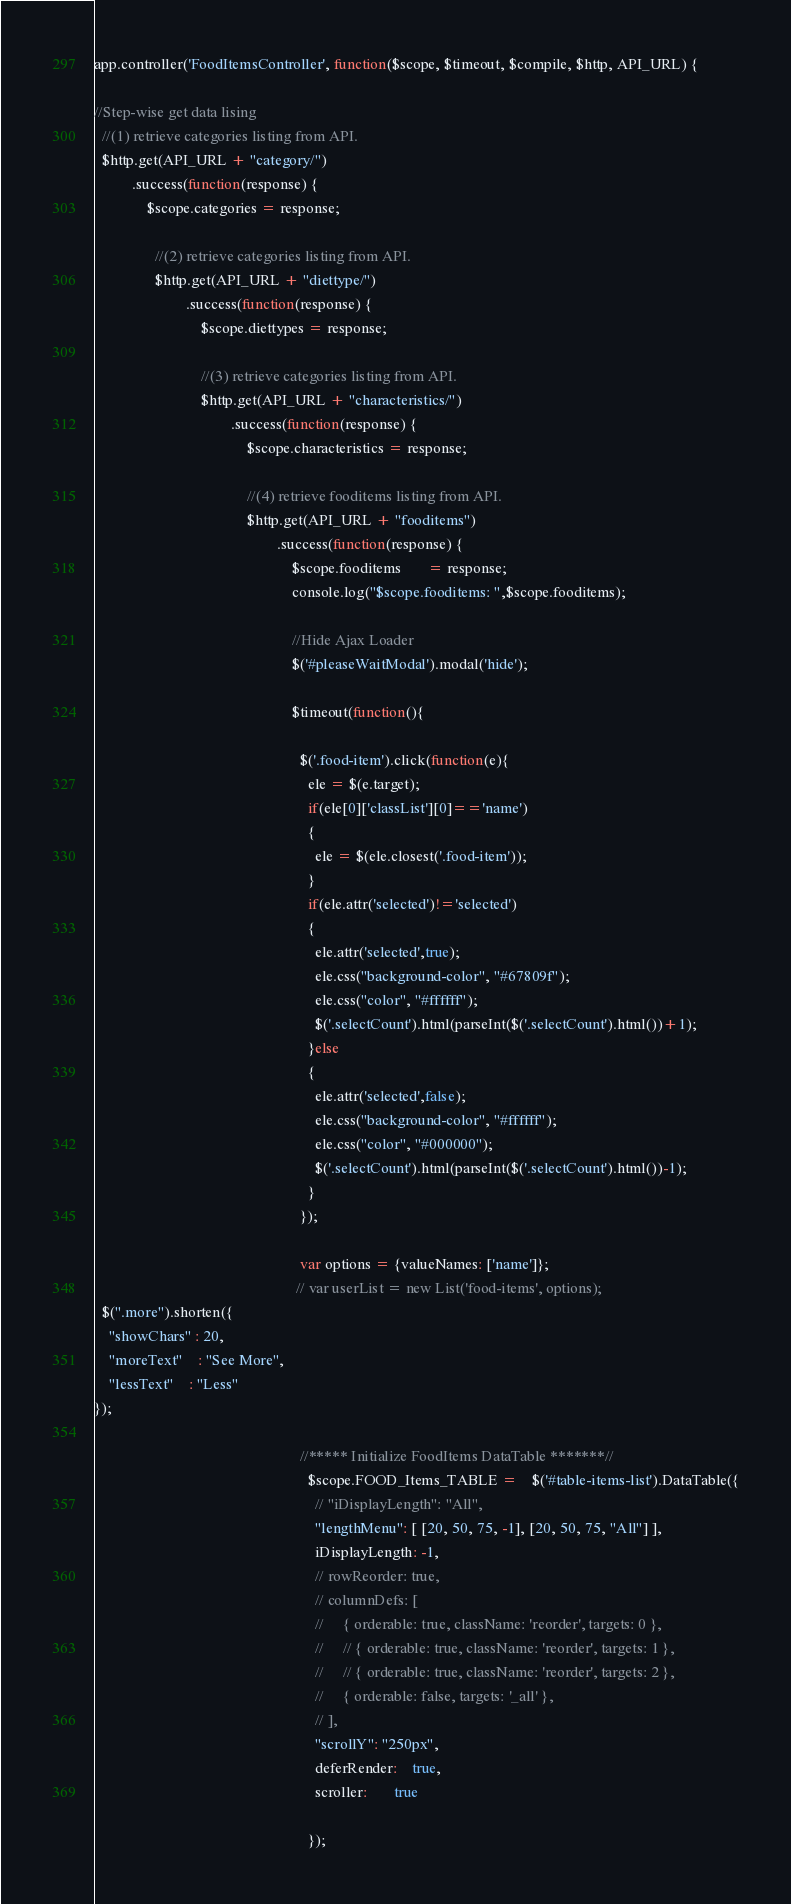<code> <loc_0><loc_0><loc_500><loc_500><_JavaScript_>app.controller('FoodItemsController', function($scope, $timeout, $compile, $http, API_URL) {

//Step-wise get data lising
  //(1) retrieve categories listing from API.
  $http.get(API_URL + "category/")
          .success(function(response) {
              $scope.categories = response;

                //(2) retrieve categories listing from API.
                $http.get(API_URL + "diettype/")
                        .success(function(response) {
                            $scope.diettypes = response;

                            //(3) retrieve categories listing from API.
                            $http.get(API_URL + "characteristics/")
                                    .success(function(response) {
                                        $scope.characteristics = response;

                                        //(4) retrieve fooditems listing from API.
                                        $http.get(API_URL + "fooditems")
                                                .success(function(response) {
                                                    $scope.fooditems       = response;
                                                    console.log("$scope.fooditems: ",$scope.fooditems);

                                                    //Hide Ajax Loader
                                                    $('#pleaseWaitModal').modal('hide');

                                                    $timeout(function(){

                                                      $('.food-item').click(function(e){
                                                        ele = $(e.target);
                                                        if(ele[0]['classList'][0]=='name')
                                                        {
                                                          ele = $(ele.closest('.food-item'));
                                                        }
                                                        if(ele.attr('selected')!='selected')
                                                        {
                                                          ele.attr('selected',true);
                                                          ele.css("background-color", "#67809f");
                                                          ele.css("color", "#ffffff");
                                                          $('.selectCount').html(parseInt($('.selectCount').html())+1);
                                                        }else
                                                        {
                                                          ele.attr('selected',false);
                                                          ele.css("background-color", "#ffffff");
                                                          ele.css("color", "#000000");
                                                          $('.selectCount').html(parseInt($('.selectCount').html())-1);
                                                        }
                                                      });

                                                      var options = {valueNames: ['name']};
                                                     // var userList = new List('food-items', options);
  $(".more").shorten({
	"showChars" : 20,
	"moreText"	: "See More",
	"lessText"	: "Less"
});

                                                      //***** Initialize FoodItems DataTable *******//
                                                        $scope.FOOD_Items_TABLE =	$('#table-items-list').DataTable({
                                                          // "iDisplayLength": "All",
                                                          "lengthMenu": [ [20, 50, 75, -1], [20, 50, 75, "All"] ],
                                                          iDisplayLength: -1,
                                                          // rowReorder: true,
                                                          // columnDefs: [
                                                          //     { orderable: true, className: 'reorder', targets: 0 },
                                                          //     // { orderable: true, className: 'reorder', targets: 1 },
                                                          //     // { orderable: true, className: 'reorder', targets: 2 },
                                                          //     { orderable: false, targets: '_all' },
                                                          // ],
                                                          "scrollY": "250px",
                                                          deferRender:    true,
                                                          scroller:       true

                                                        });
</code> 